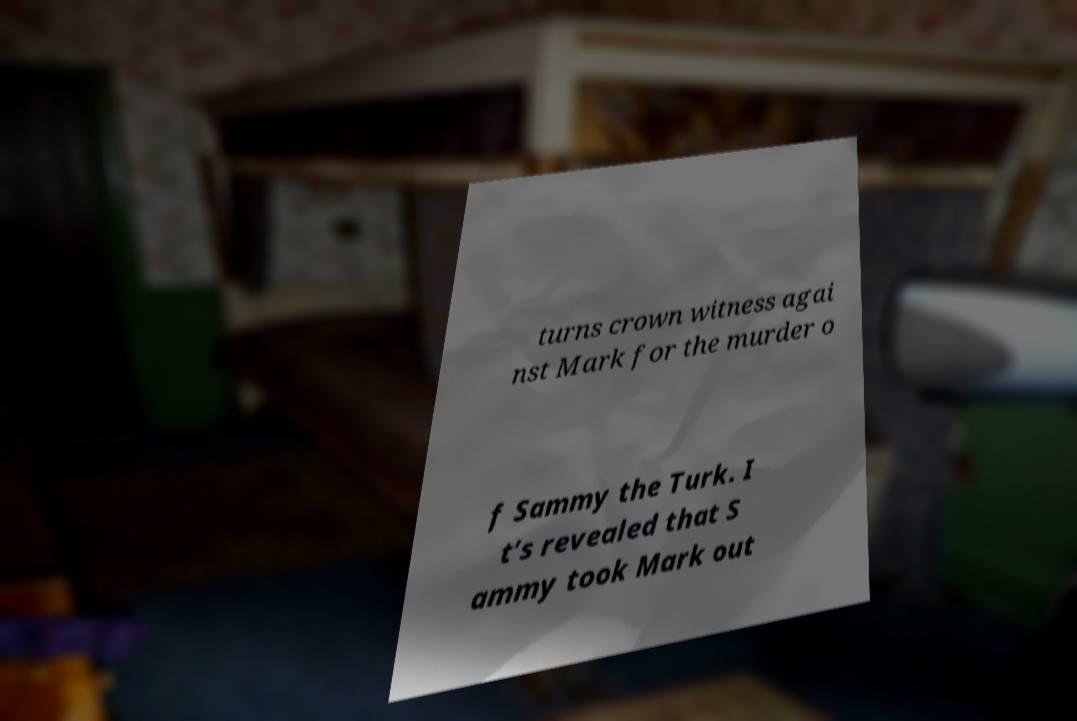I need the written content from this picture converted into text. Can you do that? turns crown witness agai nst Mark for the murder o f Sammy the Turk. I t’s revealed that S ammy took Mark out 